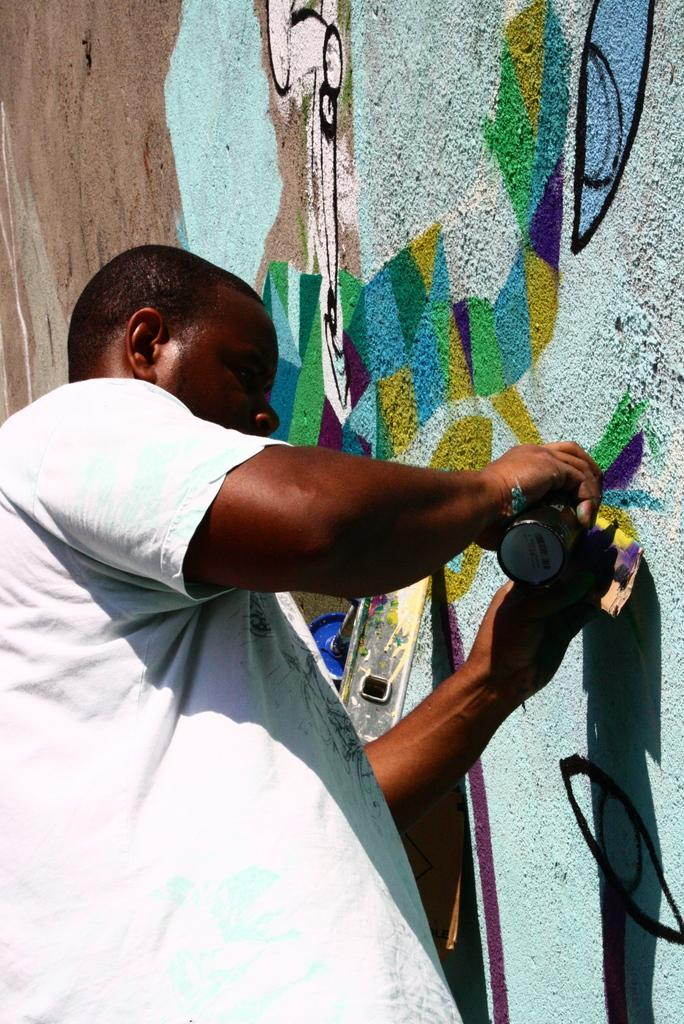What is the person in the image doing? The person is painting. What is the person wearing while painting? The person is wearing a white shirt. What can be seen in the background of the image? There is a multi-colored wall in the background of the image. How many tickets does the person have in their pocket in the image? There is no mention of tickets in the image, so it cannot be determined how many the person might have. 